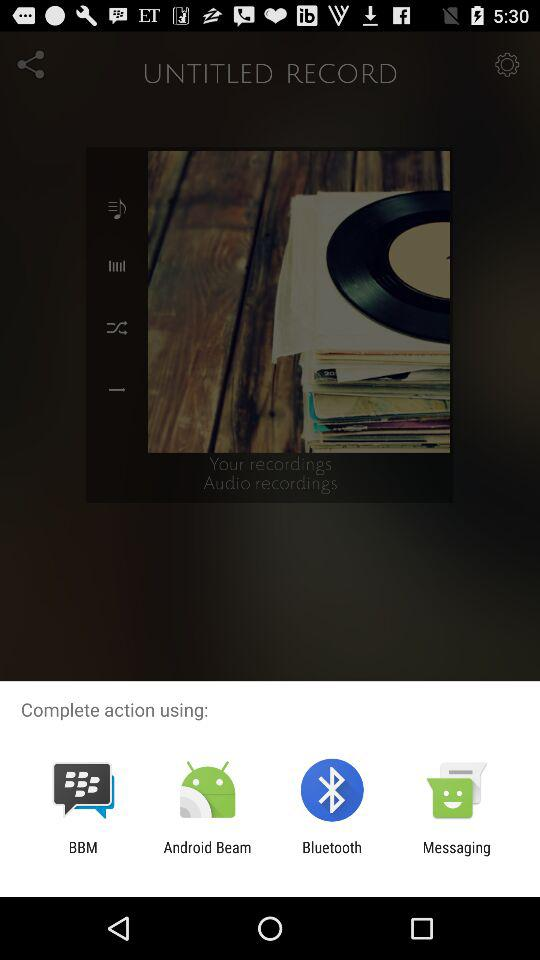What applications can be used to share? The applications that can be used to share are "BBM", "Android Beam", "Bluetooth" and "Messaging". 